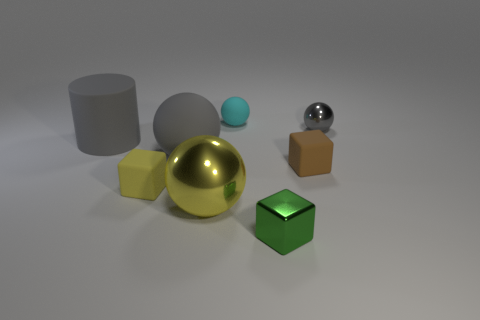Add 1 gray matte objects. How many objects exist? 9 Subtract all cylinders. How many objects are left? 7 Subtract all large yellow shiny balls. How many balls are left? 3 Subtract 1 gray cylinders. How many objects are left? 7 Subtract 3 balls. How many balls are left? 1 Subtract all yellow cylinders. Subtract all gray blocks. How many cylinders are left? 1 Subtract all yellow balls. How many cyan cylinders are left? 0 Subtract all tiny brown matte cubes. Subtract all small objects. How many objects are left? 2 Add 8 tiny green metal things. How many tiny green metal things are left? 9 Add 2 tiny things. How many tiny things exist? 7 